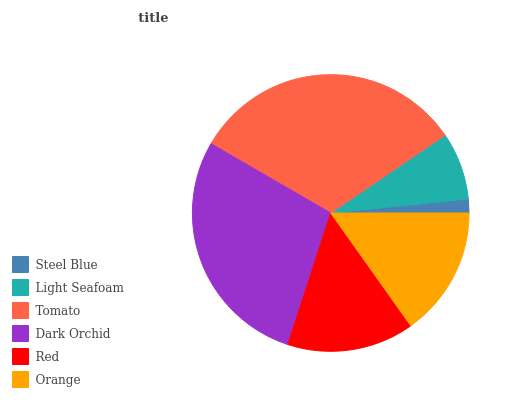Is Steel Blue the minimum?
Answer yes or no. Yes. Is Tomato the maximum?
Answer yes or no. Yes. Is Light Seafoam the minimum?
Answer yes or no. No. Is Light Seafoam the maximum?
Answer yes or no. No. Is Light Seafoam greater than Steel Blue?
Answer yes or no. Yes. Is Steel Blue less than Light Seafoam?
Answer yes or no. Yes. Is Steel Blue greater than Light Seafoam?
Answer yes or no. No. Is Light Seafoam less than Steel Blue?
Answer yes or no. No. Is Orange the high median?
Answer yes or no. Yes. Is Red the low median?
Answer yes or no. Yes. Is Dark Orchid the high median?
Answer yes or no. No. Is Tomato the low median?
Answer yes or no. No. 